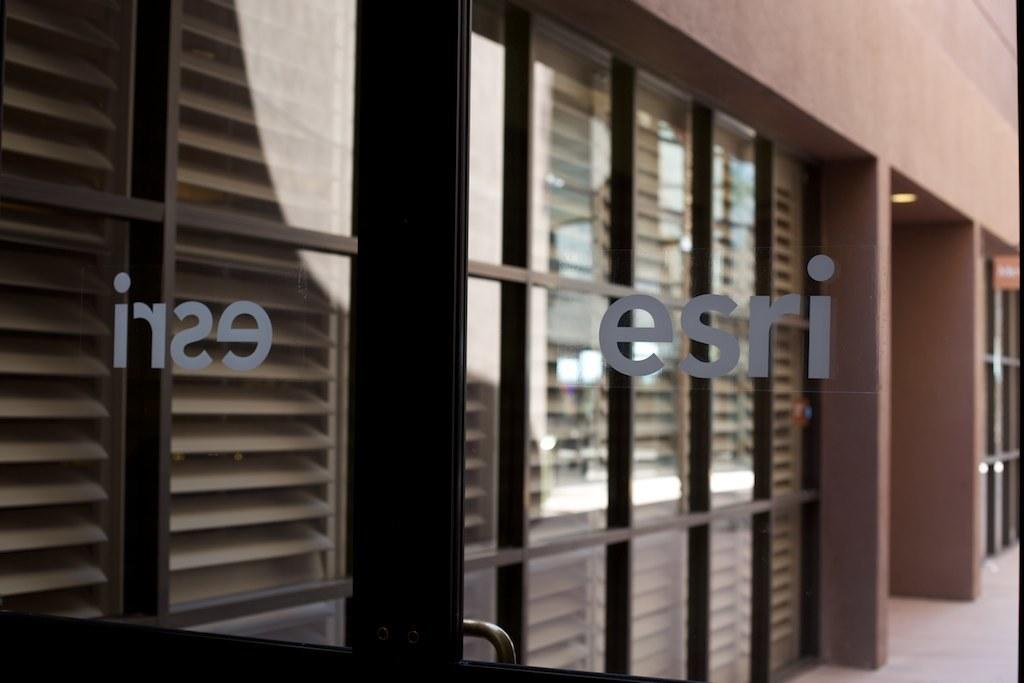What type of structure is present in the image? There is a building in the image. What feature can be observed on the building? The building has a glass wall. Where is the text located in the image? The text is visible on the front side of the image. How many ladybugs can be seen crawling on the glass wall of the building in the image? There are no ladybugs present in the image; the glass wall is the only feature mentioned. 